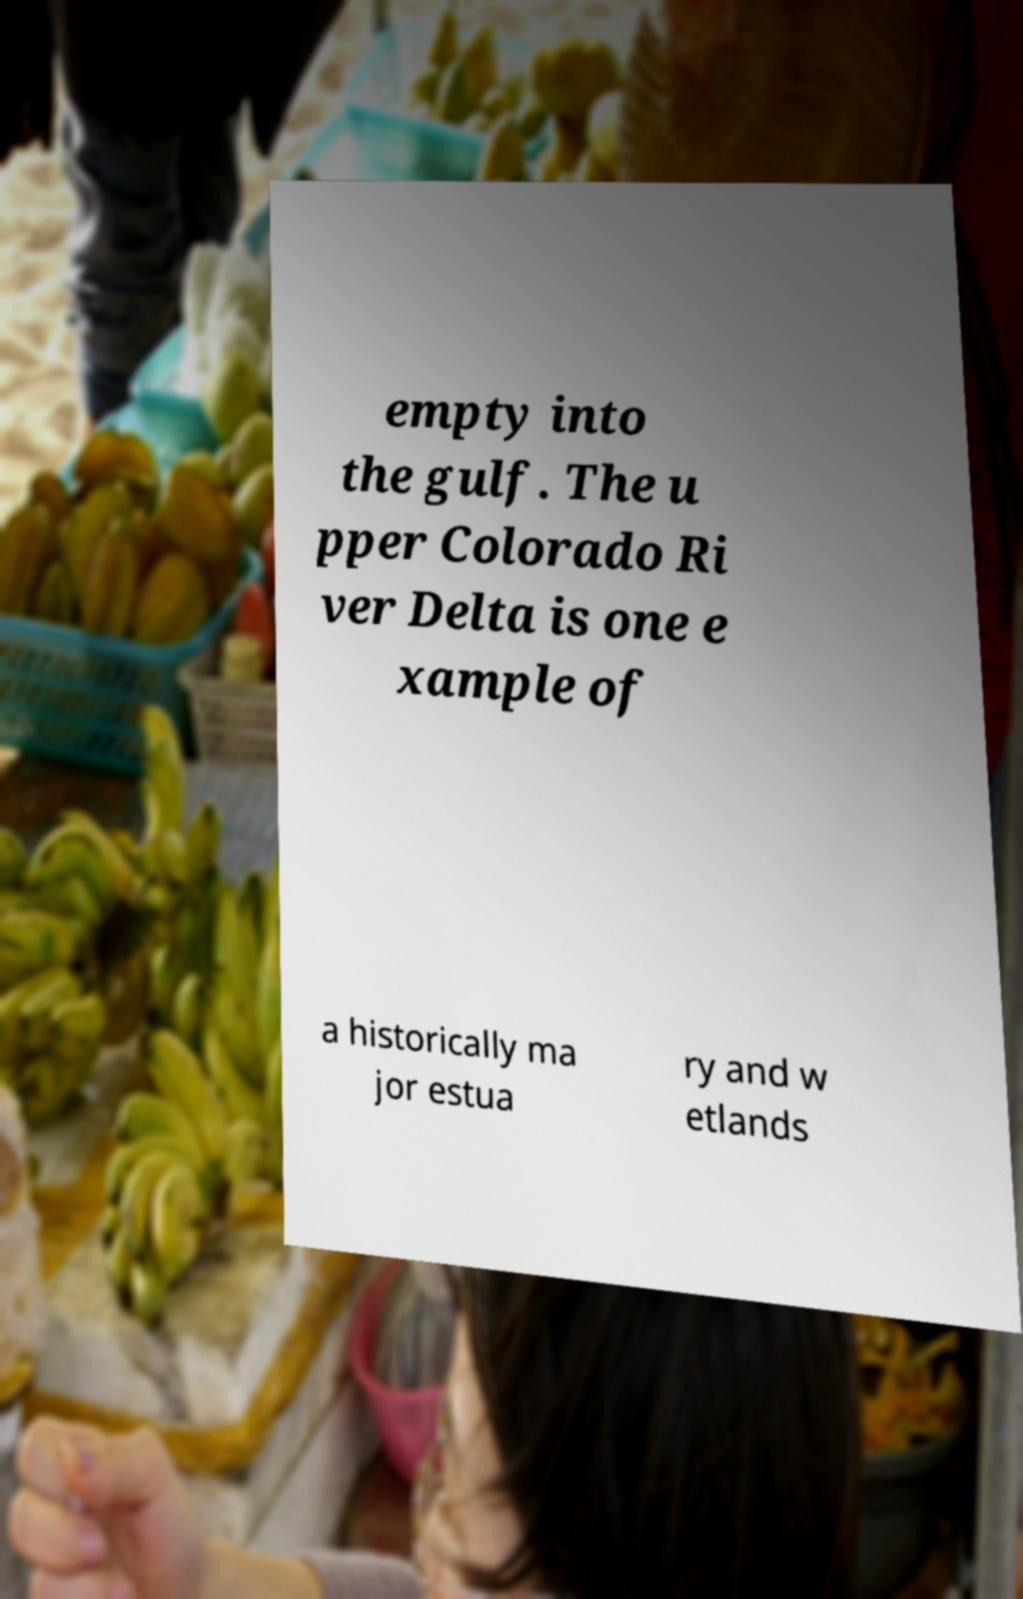Can you accurately transcribe the text from the provided image for me? empty into the gulf. The u pper Colorado Ri ver Delta is one e xample of a historically ma jor estua ry and w etlands 